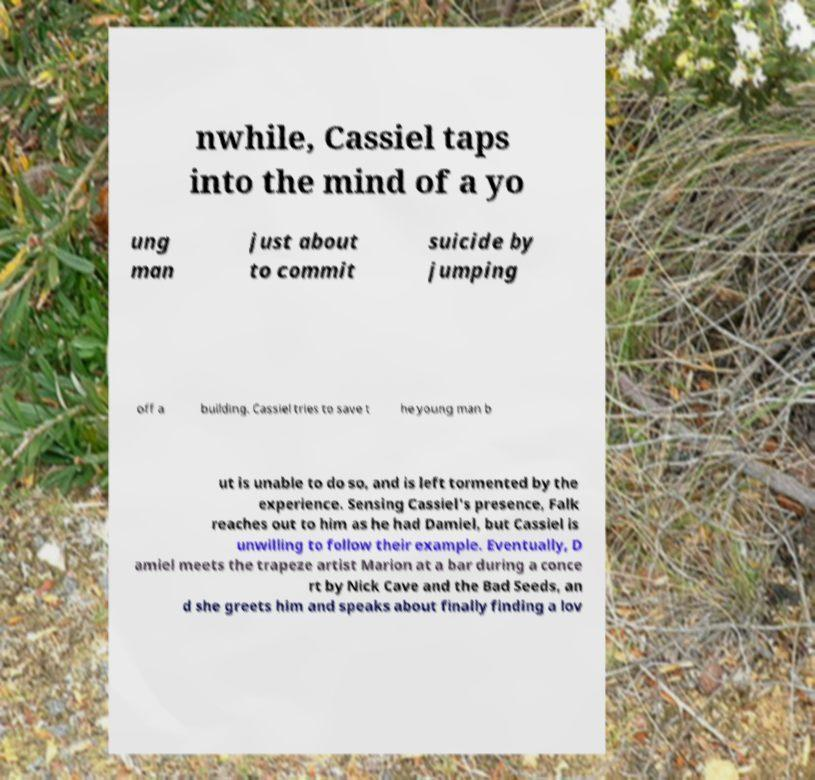Could you assist in decoding the text presented in this image and type it out clearly? nwhile, Cassiel taps into the mind of a yo ung man just about to commit suicide by jumping off a building. Cassiel tries to save t he young man b ut is unable to do so, and is left tormented by the experience. Sensing Cassiel's presence, Falk reaches out to him as he had Damiel, but Cassiel is unwilling to follow their example. Eventually, D amiel meets the trapeze artist Marion at a bar during a conce rt by Nick Cave and the Bad Seeds, an d she greets him and speaks about finally finding a lov 